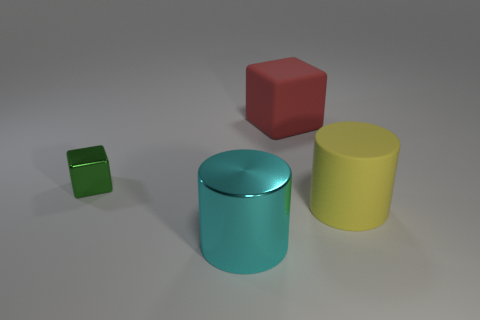Add 1 red things. How many objects exist? 5 Add 1 yellow matte objects. How many yellow matte objects exist? 2 Subtract 0 gray cylinders. How many objects are left? 4 Subtract all small cyan shiny balls. Subtract all green cubes. How many objects are left? 3 Add 2 green shiny things. How many green shiny things are left? 3 